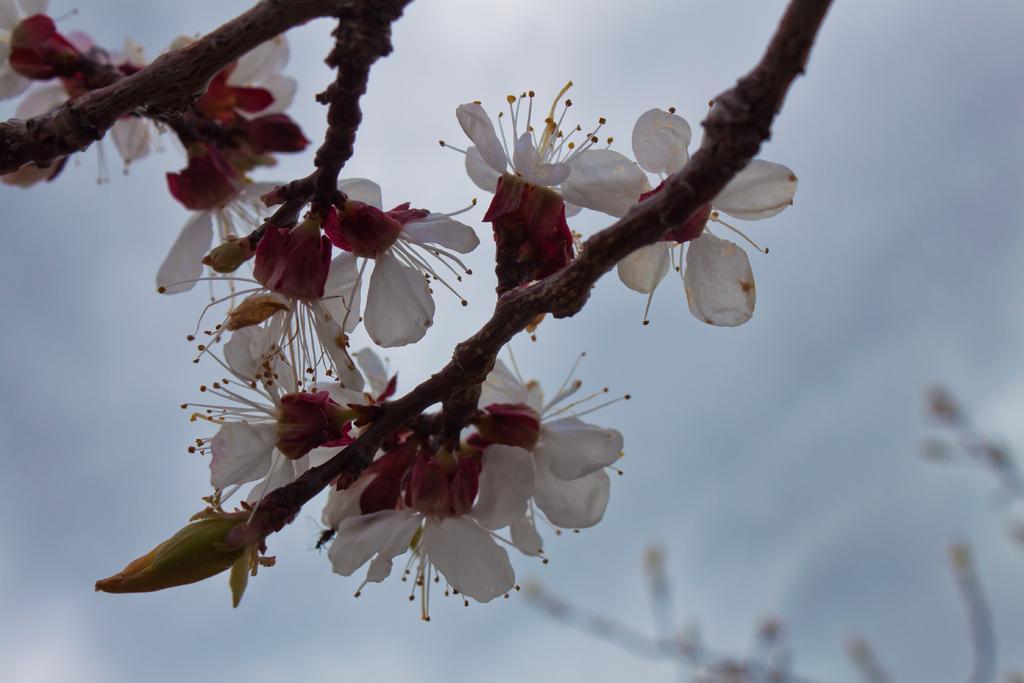How would you summarize this image in a sentence or two? In this image we can see flowers and stems. 